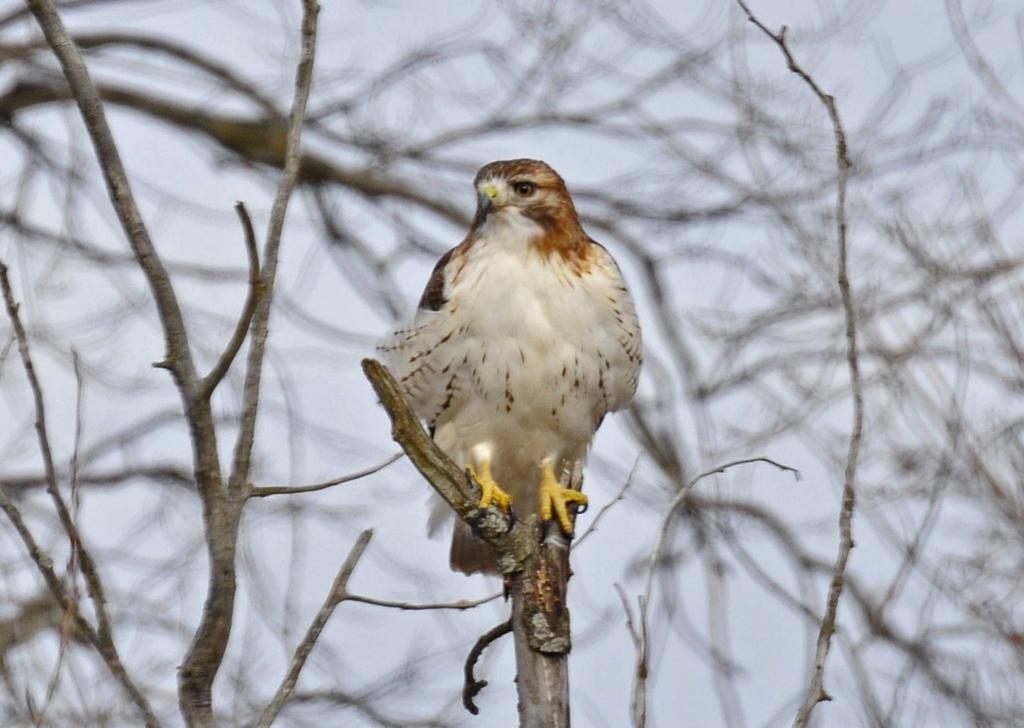Can you describe this image briefly? In this image there is an eagle on a branch of a tree, in the background there are branches and the sky and it is blurred. 